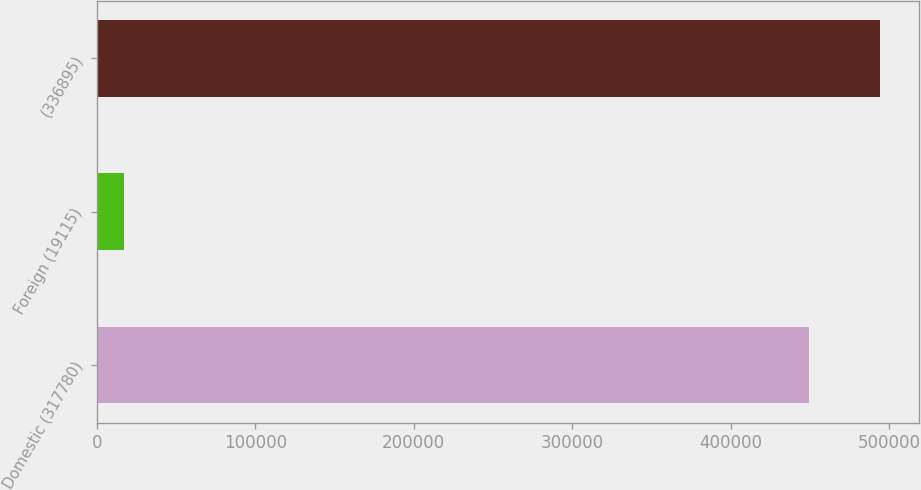Convert chart. <chart><loc_0><loc_0><loc_500><loc_500><bar_chart><fcel>Domestic (317780)<fcel>Foreign (19115)<fcel>(336895)<nl><fcel>448995<fcel>17345<fcel>493894<nl></chart> 